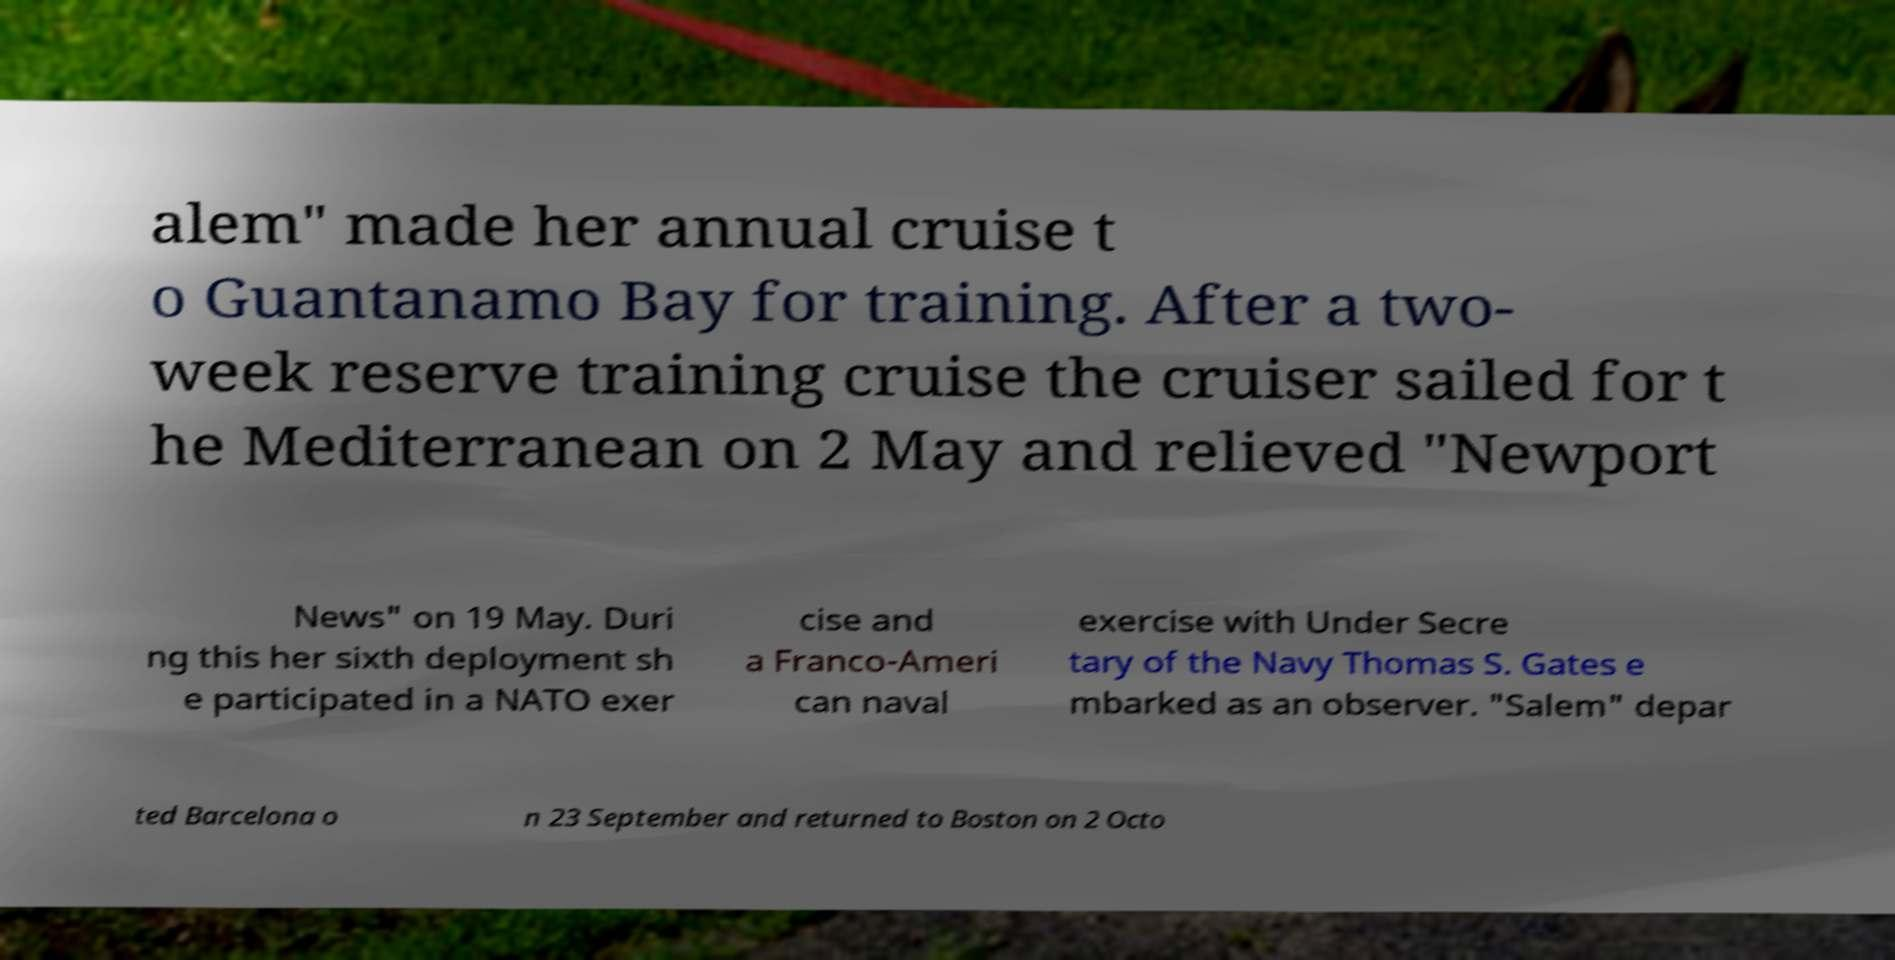Could you assist in decoding the text presented in this image and type it out clearly? alem" made her annual cruise t o Guantanamo Bay for training. After a two- week reserve training cruise the cruiser sailed for t he Mediterranean on 2 May and relieved "Newport News" on 19 May. Duri ng this her sixth deployment sh e participated in a NATO exer cise and a Franco-Ameri can naval exercise with Under Secre tary of the Navy Thomas S. Gates e mbarked as an observer. "Salem" depar ted Barcelona o n 23 September and returned to Boston on 2 Octo 